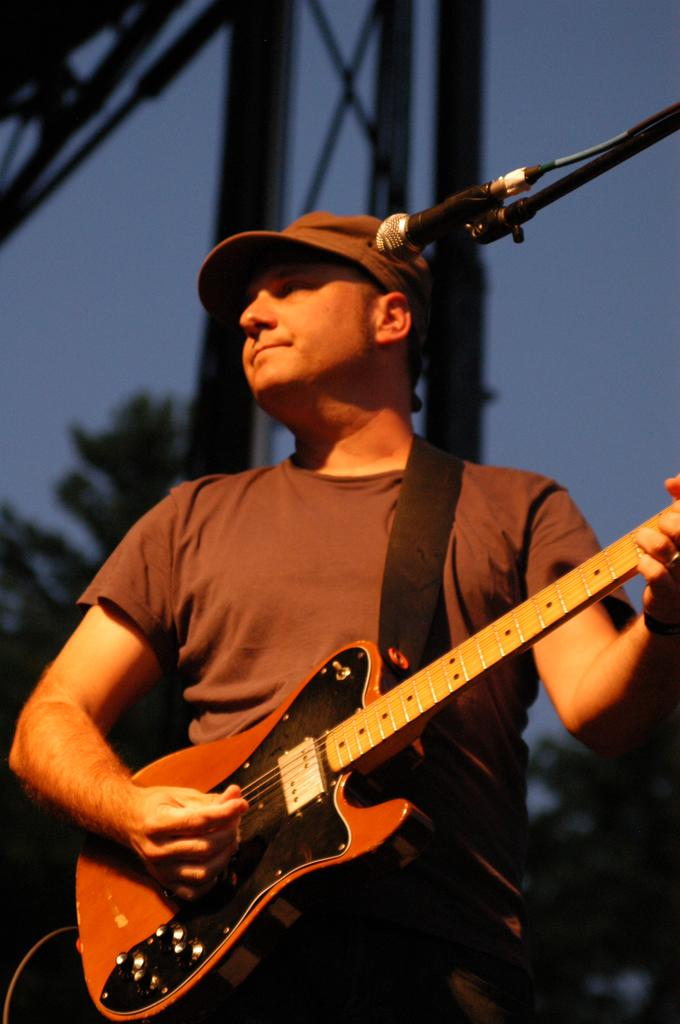Who is present in the image? There is a man in the image. What is the man wearing on his head? The man is wearing a cap. What object is the man holding in the image? The man is holding a guitar. What device is visible in the image that is used for amplifying sound? There is a microphone in the image. What type of meal is the man eating in the image? There is no meal present in the image; the man is holding a guitar and there is a microphone nearby. 